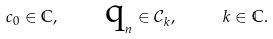Convert formula to latex. <formula><loc_0><loc_0><loc_500><loc_500>c _ { 0 } \in \mathbb { C } , \text { \quad q} _ { n } \in \mathcal { C } _ { k } , \text { \quad } k \in \mathbb { C } .</formula> 